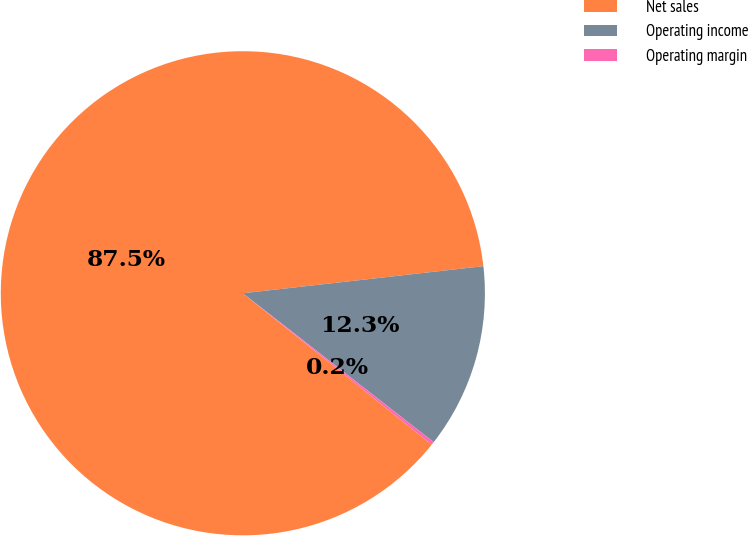Convert chart to OTSL. <chart><loc_0><loc_0><loc_500><loc_500><pie_chart><fcel>Net sales<fcel>Operating income<fcel>Operating margin<nl><fcel>87.46%<fcel>12.33%<fcel>0.21%<nl></chart> 